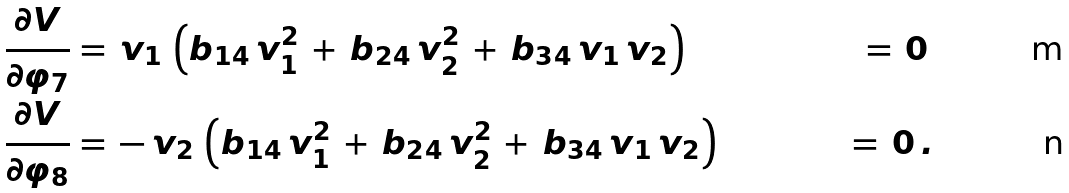<formula> <loc_0><loc_0><loc_500><loc_500>\frac { \partial V } { \partial \varphi _ { 7 } } & = \, v _ { 1 } \, \left ( b _ { 1 4 } \, v _ { 1 } ^ { 2 } \, + \, b _ { 2 4 } \, v _ { 2 } ^ { 2 } \, + \, b _ { 3 4 } \, v _ { 1 } \, v _ { 2 } \right ) & \, = \, 0 \, \\ \frac { \partial V } { \partial \varphi _ { 8 } } & = \, - \, v _ { 2 } \, \left ( b _ { 1 4 } \, v _ { 1 } ^ { 2 } \, + \, b _ { 2 4 } \, v _ { 2 } ^ { 2 } \, + \, b _ { 3 4 } \, v _ { 1 } \, v _ { 2 } \right ) & \, = \, 0 \, .</formula> 